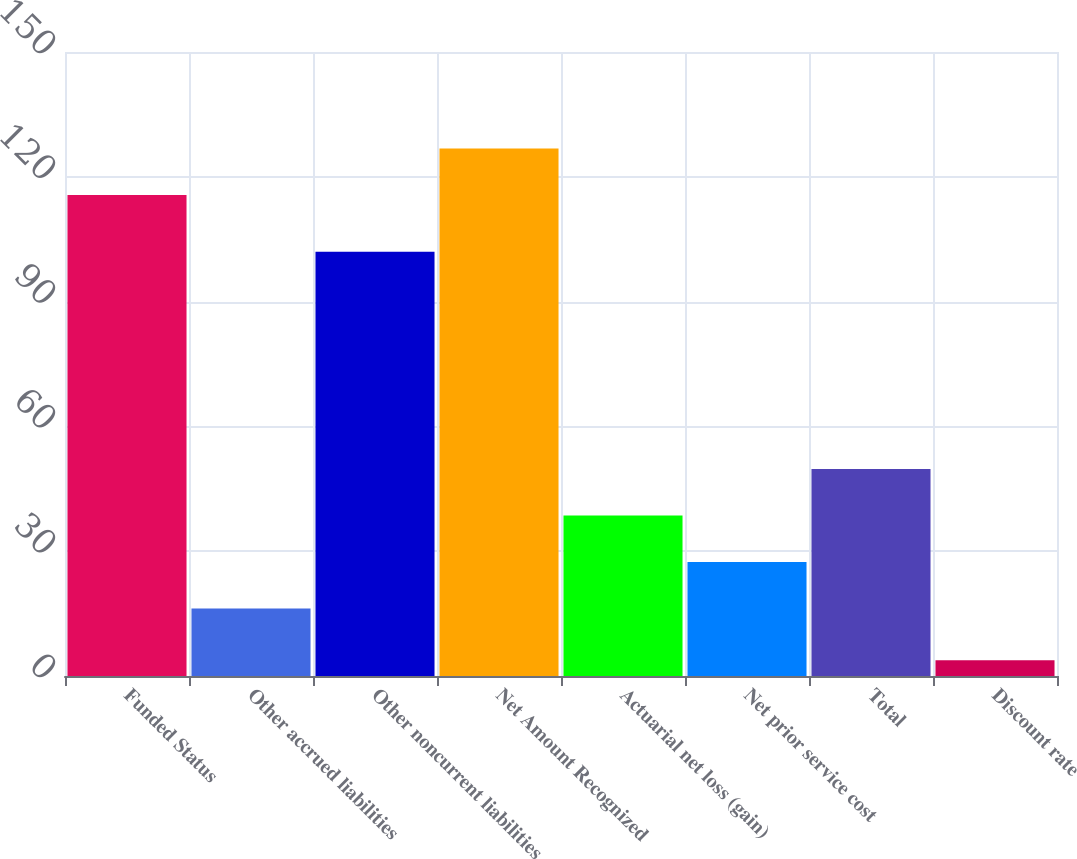Convert chart to OTSL. <chart><loc_0><loc_0><loc_500><loc_500><bar_chart><fcel>Funded Status<fcel>Other accrued liabilities<fcel>Other noncurrent liabilities<fcel>Net Amount Recognized<fcel>Actuarial net loss (gain)<fcel>Net prior service cost<fcel>Total<fcel>Discount rate<nl><fcel>115.6<fcel>16.2<fcel>102<fcel>126.78<fcel>38.56<fcel>27.38<fcel>49.74<fcel>3.81<nl></chart> 